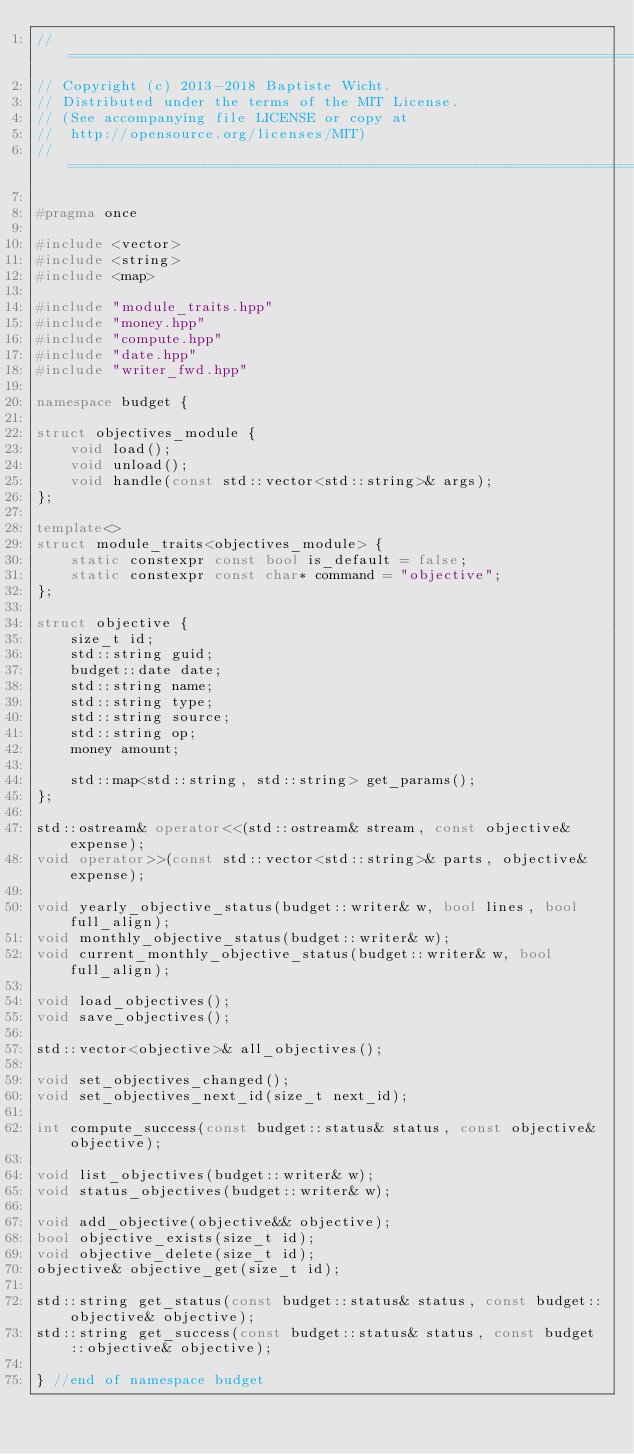Convert code to text. <code><loc_0><loc_0><loc_500><loc_500><_C++_>//=======================================================================
// Copyright (c) 2013-2018 Baptiste Wicht.
// Distributed under the terms of the MIT License.
// (See accompanying file LICENSE or copy at
//  http://opensource.org/licenses/MIT)
//=======================================================================

#pragma once

#include <vector>
#include <string>
#include <map>

#include "module_traits.hpp"
#include "money.hpp"
#include "compute.hpp"
#include "date.hpp"
#include "writer_fwd.hpp"

namespace budget {

struct objectives_module {
    void load();
    void unload();
    void handle(const std::vector<std::string>& args);
};

template<>
struct module_traits<objectives_module> {
    static constexpr const bool is_default = false;
    static constexpr const char* command = "objective";
};

struct objective {
    size_t id;
    std::string guid;
    budget::date date;
    std::string name;
    std::string type;
    std::string source;
    std::string op;
    money amount;

    std::map<std::string, std::string> get_params();
};

std::ostream& operator<<(std::ostream& stream, const objective& expense);
void operator>>(const std::vector<std::string>& parts, objective& expense);

void yearly_objective_status(budget::writer& w, bool lines, bool full_align);
void monthly_objective_status(budget::writer& w);
void current_monthly_objective_status(budget::writer& w, bool full_align);

void load_objectives();
void save_objectives();

std::vector<objective>& all_objectives();

void set_objectives_changed();
void set_objectives_next_id(size_t next_id);

int compute_success(const budget::status& status, const objective& objective);

void list_objectives(budget::writer& w);
void status_objectives(budget::writer& w);

void add_objective(objective&& objective);
bool objective_exists(size_t id);
void objective_delete(size_t id);
objective& objective_get(size_t id);

std::string get_status(const budget::status& status, const budget::objective& objective);
std::string get_success(const budget::status& status, const budget::objective& objective);

} //end of namespace budget
</code> 